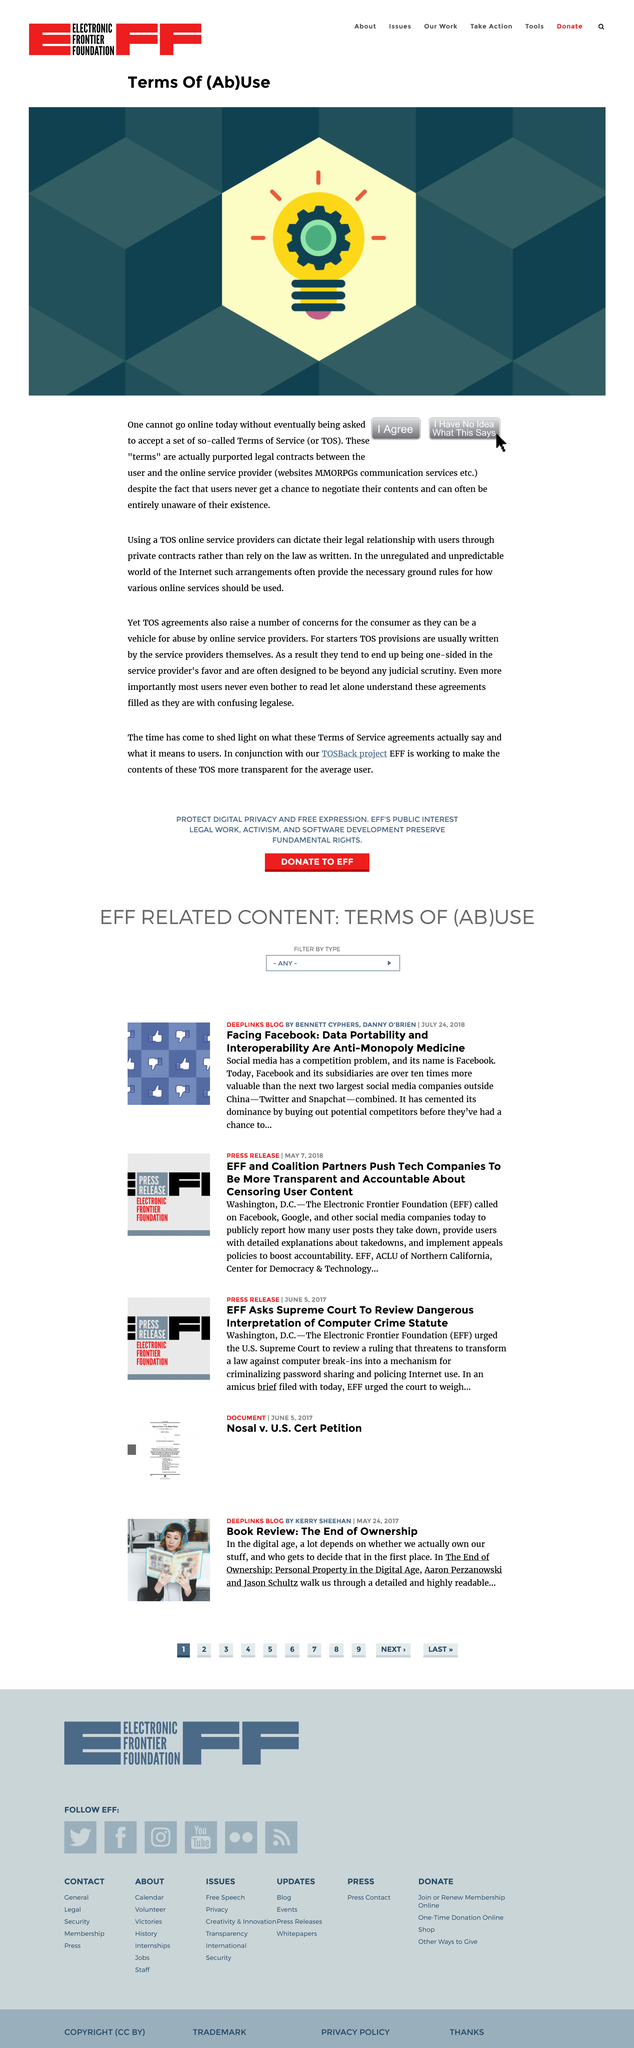Mention a couple of crucial points in this snapshot. Terms of Service, commonly referred to as TOS, is a set of rules and regulations that govern the use of a particular product, service, or platform. By clicking "I Agree" on the website, the user is declaring that they accept the website's terms of service. Terms of service are purported legal contracts between online service providers and their users. 